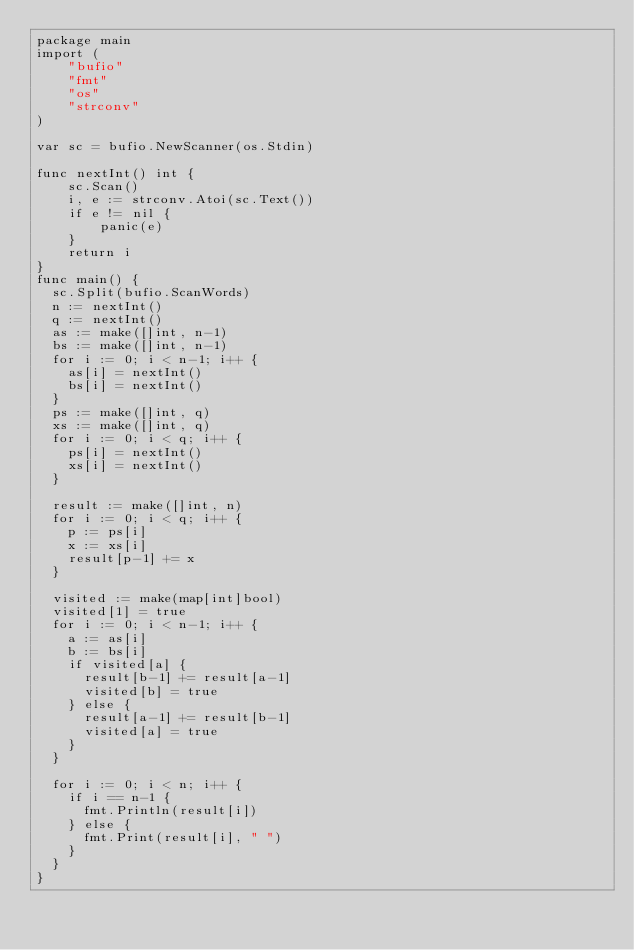Convert code to text. <code><loc_0><loc_0><loc_500><loc_500><_Go_>package main
import (
    "bufio"
    "fmt"
    "os"
    "strconv"
)

var sc = bufio.NewScanner(os.Stdin)

func nextInt() int {
    sc.Scan()
    i, e := strconv.Atoi(sc.Text())
    if e != nil {
        panic(e)
    }
    return i
}
func main() {
  sc.Split(bufio.ScanWords)
  n := nextInt()
  q := nextInt()
  as := make([]int, n-1)
  bs := make([]int, n-1)
  for i := 0; i < n-1; i++ {
    as[i] = nextInt()
    bs[i] = nextInt()
  }
  ps := make([]int, q)
  xs := make([]int, q)
  for i := 0; i < q; i++ {
    ps[i] = nextInt()
    xs[i] = nextInt()
  }
  
  result := make([]int, n)
  for i := 0; i < q; i++ {
    p := ps[i]
    x := xs[i]
    result[p-1] += x
  }
  
  visited := make(map[int]bool)
  visited[1] = true
  for i := 0; i < n-1; i++ {
    a := as[i]
    b := bs[i]
    if visited[a] {
      result[b-1] += result[a-1]
      visited[b] = true
    } else {
      result[a-1] += result[b-1]
      visited[a] = true
    }
  }
  
  for i := 0; i < n; i++ {
    if i == n-1 {
      fmt.Println(result[i])
    } else {
      fmt.Print(result[i], " ")
    }
  }
}</code> 